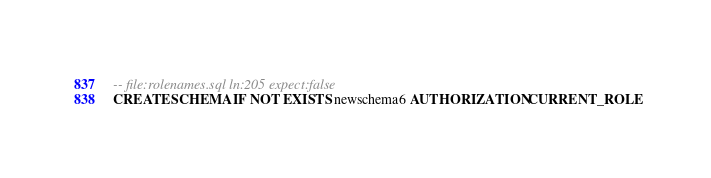<code> <loc_0><loc_0><loc_500><loc_500><_SQL_>-- file:rolenames.sql ln:205 expect:false
CREATE SCHEMA IF NOT EXISTS newschema6 AUTHORIZATION CURRENT_ROLE
</code> 